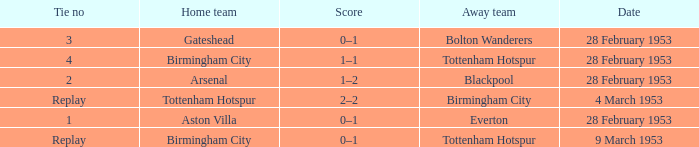Which Home team has a Score of 0–1, and an Away team of tottenham hotspur? Birmingham City. 